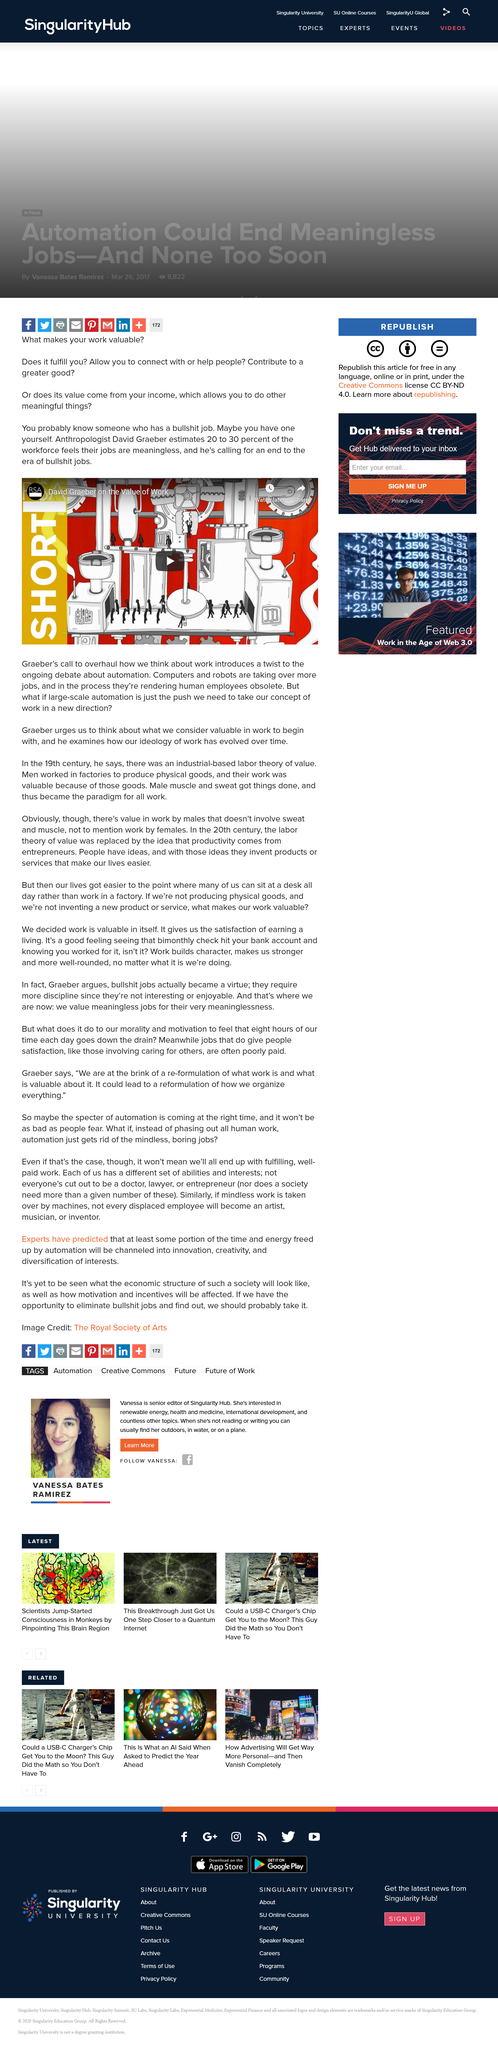List a handful of essential elements in this visual. The text begins with direct questions posed to the reader. David Graeber is an anthropologist known for his influential work in the field. David Graeber argues that not all jobs are important, and he advocates for the end of the era of bullshit jobs. 